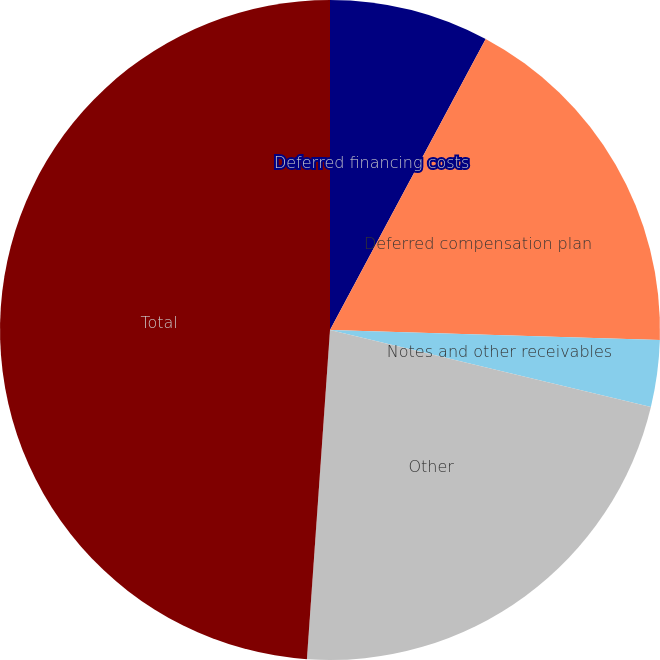<chart> <loc_0><loc_0><loc_500><loc_500><pie_chart><fcel>Deferred financing costs<fcel>Deferred compensation plan<fcel>Notes and other receivables<fcel>Other<fcel>Total<nl><fcel>7.82%<fcel>17.67%<fcel>3.26%<fcel>22.37%<fcel>48.89%<nl></chart> 